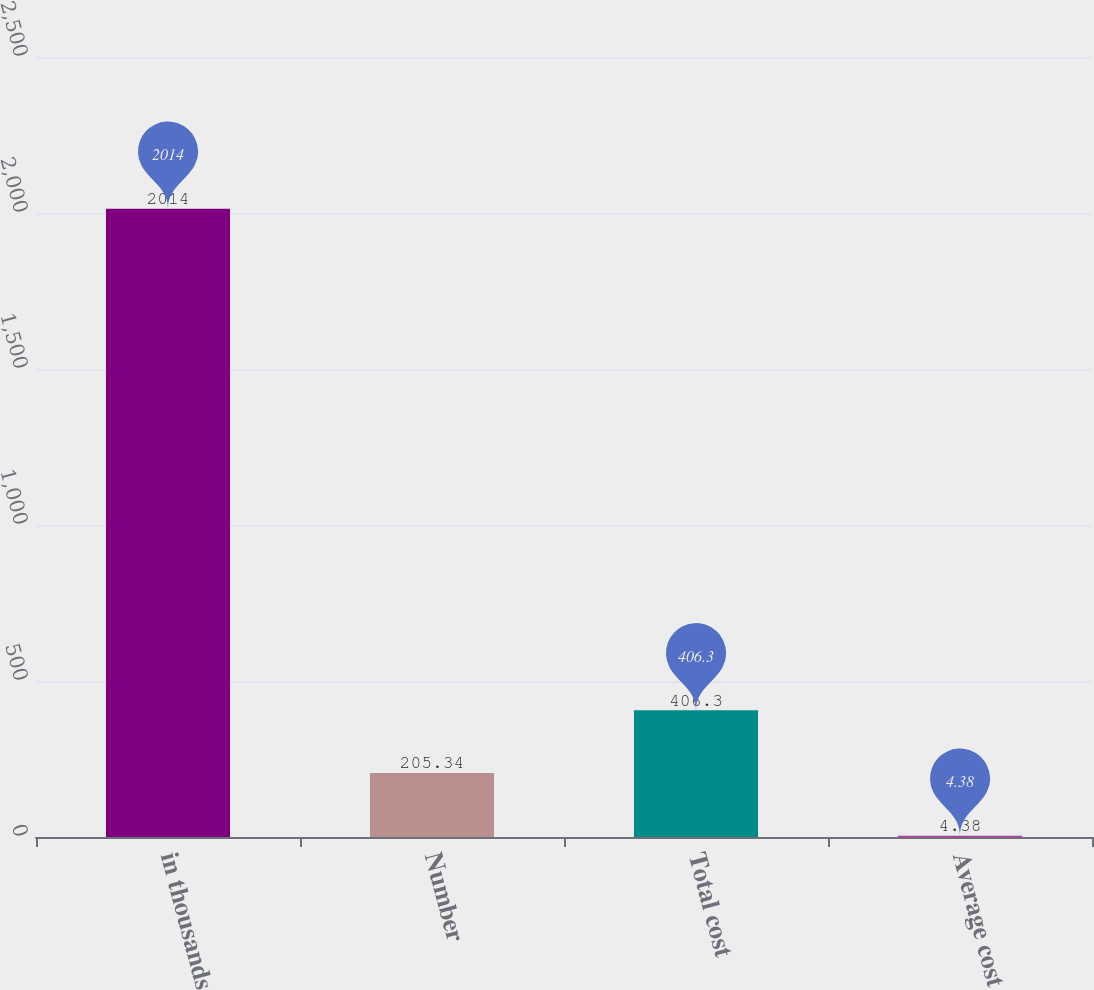Convert chart. <chart><loc_0><loc_0><loc_500><loc_500><bar_chart><fcel>in thousands<fcel>Number<fcel>Total cost<fcel>Average cost<nl><fcel>2014<fcel>205.34<fcel>406.3<fcel>4.38<nl></chart> 